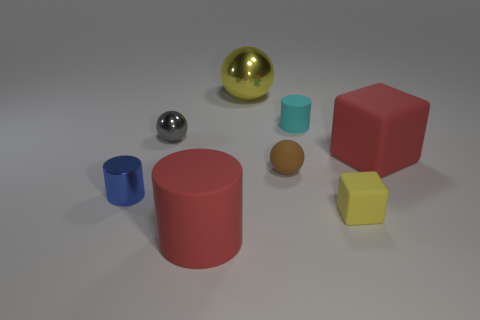There is a big metal thing; is its color the same as the tiny thing that is in front of the small shiny cylinder?
Ensure brevity in your answer.  Yes. What material is the thing that is the same color as the tiny block?
Ensure brevity in your answer.  Metal. What is the size of the cube that is the same color as the big metallic ball?
Offer a very short reply. Small. Do the big sphere and the small matte cube have the same color?
Offer a very short reply. Yes. Is the number of rubber balls that are in front of the brown rubber sphere less than the number of yellow things that are to the right of the big yellow metallic sphere?
Give a very brief answer. Yes. There is a tiny blue thing that is made of the same material as the small gray ball; what shape is it?
Offer a terse response. Cylinder. Is there anything else that is the same color as the big matte cylinder?
Make the answer very short. Yes. What color is the matte cylinder on the right side of the red thing in front of the small yellow matte thing?
Provide a short and direct response. Cyan. What is the cylinder left of the red thing that is to the left of the rubber block that is behind the small brown rubber ball made of?
Offer a very short reply. Metal. What number of brown cubes have the same size as the gray metal ball?
Keep it short and to the point. 0. 